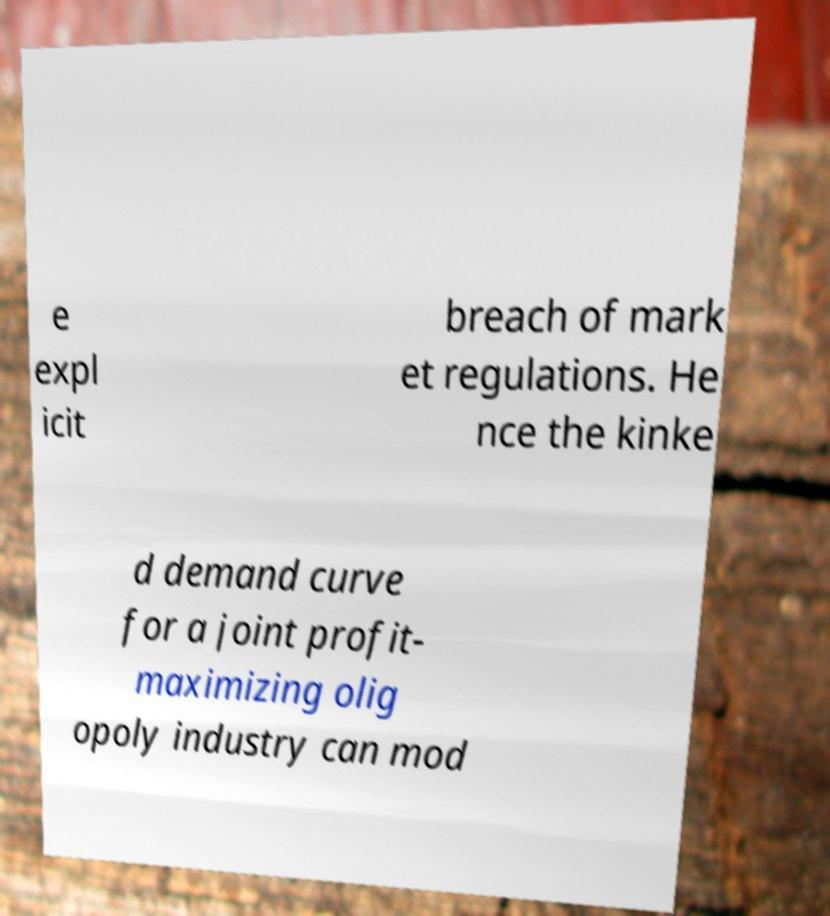Please read and relay the text visible in this image. What does it say? e expl icit breach of mark et regulations. He nce the kinke d demand curve for a joint profit- maximizing olig opoly industry can mod 